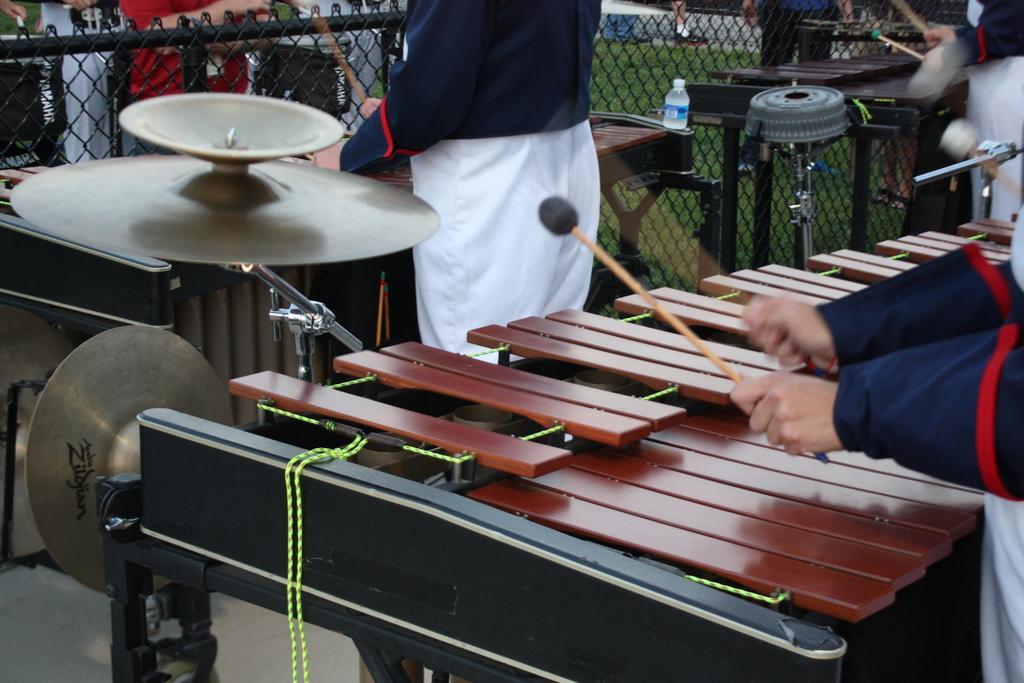Could you give a brief overview of what you see in this image? In this image I can see few persons playing some musical instruments. There are some tables. At the top of the image there is a net fencing. Behind the fencing few people are standing. 